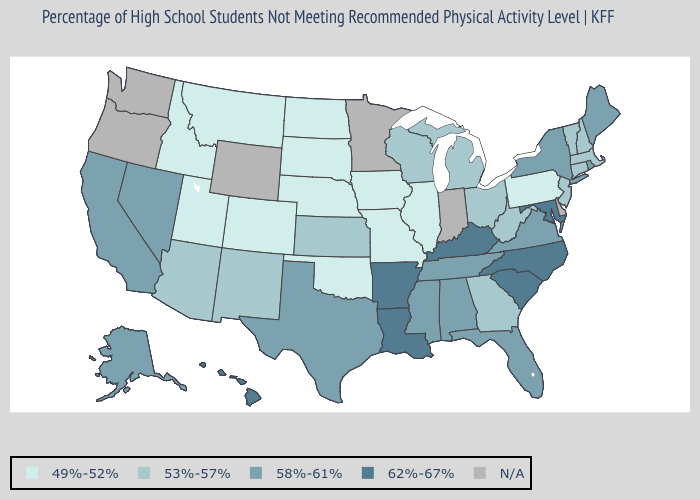What is the value of Indiana?
Short answer required. N/A. What is the value of Maine?
Concise answer only. 58%-61%. Among the states that border California , which have the lowest value?
Give a very brief answer. Arizona. Name the states that have a value in the range 62%-67%?
Quick response, please. Arkansas, Hawaii, Kentucky, Louisiana, Maryland, North Carolina, South Carolina. Does the first symbol in the legend represent the smallest category?
Write a very short answer. Yes. Name the states that have a value in the range 49%-52%?
Short answer required. Colorado, Idaho, Illinois, Iowa, Missouri, Montana, Nebraska, North Dakota, Oklahoma, Pennsylvania, South Dakota, Utah. Name the states that have a value in the range 49%-52%?
Short answer required. Colorado, Idaho, Illinois, Iowa, Missouri, Montana, Nebraska, North Dakota, Oklahoma, Pennsylvania, South Dakota, Utah. What is the highest value in the USA?
Keep it brief. 62%-67%. What is the lowest value in the Northeast?
Concise answer only. 49%-52%. Does the first symbol in the legend represent the smallest category?
Be succinct. Yes. Which states have the lowest value in the Northeast?
Short answer required. Pennsylvania. What is the value of Montana?
Give a very brief answer. 49%-52%. What is the value of New Mexico?
Give a very brief answer. 53%-57%. What is the value of Wisconsin?
Write a very short answer. 53%-57%. 